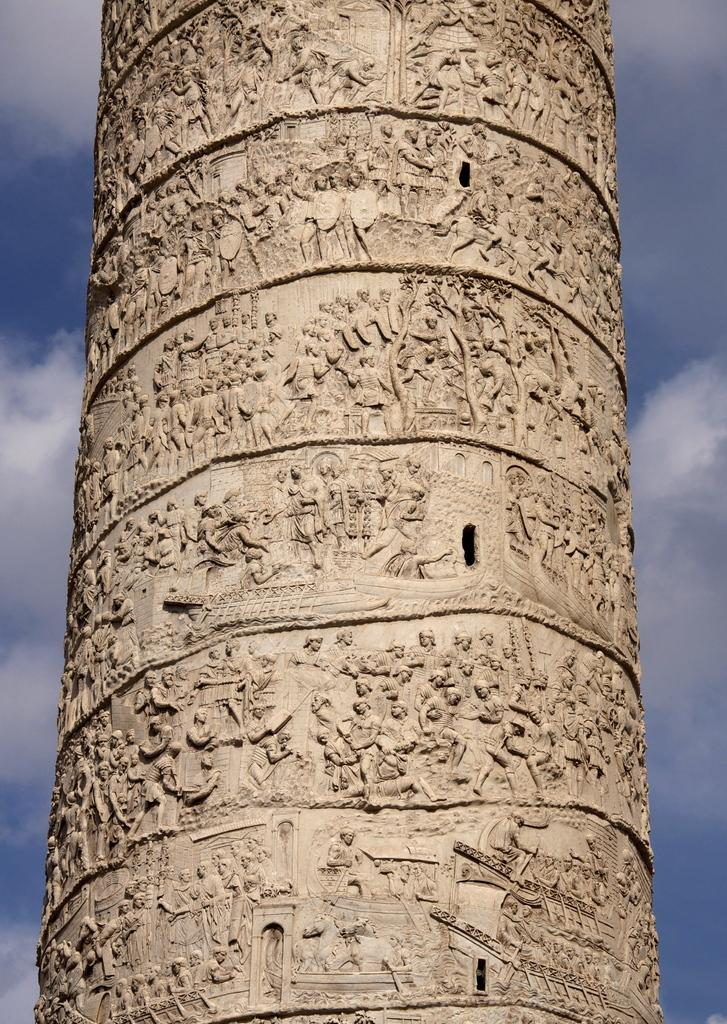What is the main subject of the image? The main subject of the image is a pillar with carving. What can be seen in the background of the image? The sky is visible in the image. How would you describe the sky in the image? The sky appears to be cloudy. How many fingers can be seen on the pillar in the image? There are no fingers present on the pillar in the image; it is a carved structure. What type of glass object is visible in the image? There is no glass object present in the image. 